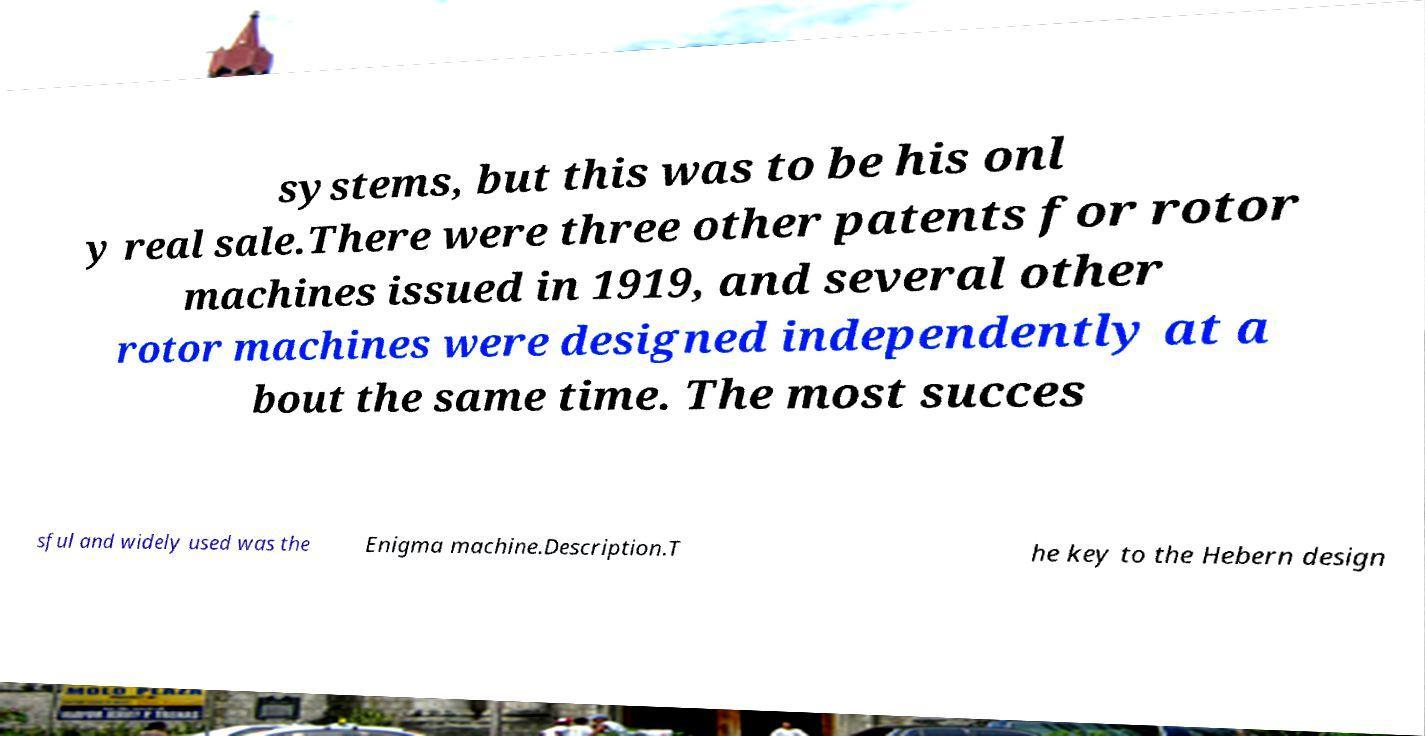For documentation purposes, I need the text within this image transcribed. Could you provide that? systems, but this was to be his onl y real sale.There were three other patents for rotor machines issued in 1919, and several other rotor machines were designed independently at a bout the same time. The most succes sful and widely used was the Enigma machine.Description.T he key to the Hebern design 